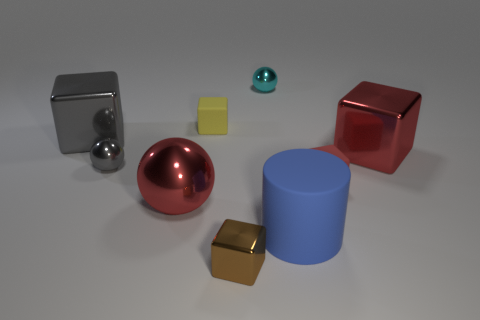Subtract all yellow rubber blocks. How many blocks are left? 4 Subtract all green blocks. Subtract all blue cylinders. How many blocks are left? 5 Add 1 tiny things. How many objects exist? 10 Subtract all balls. How many objects are left? 6 Subtract 0 cyan cylinders. How many objects are left? 9 Subtract all cyan rubber cubes. Subtract all small red matte objects. How many objects are left? 8 Add 4 large red metal spheres. How many large red metal spheres are left? 5 Add 6 big blocks. How many big blocks exist? 8 